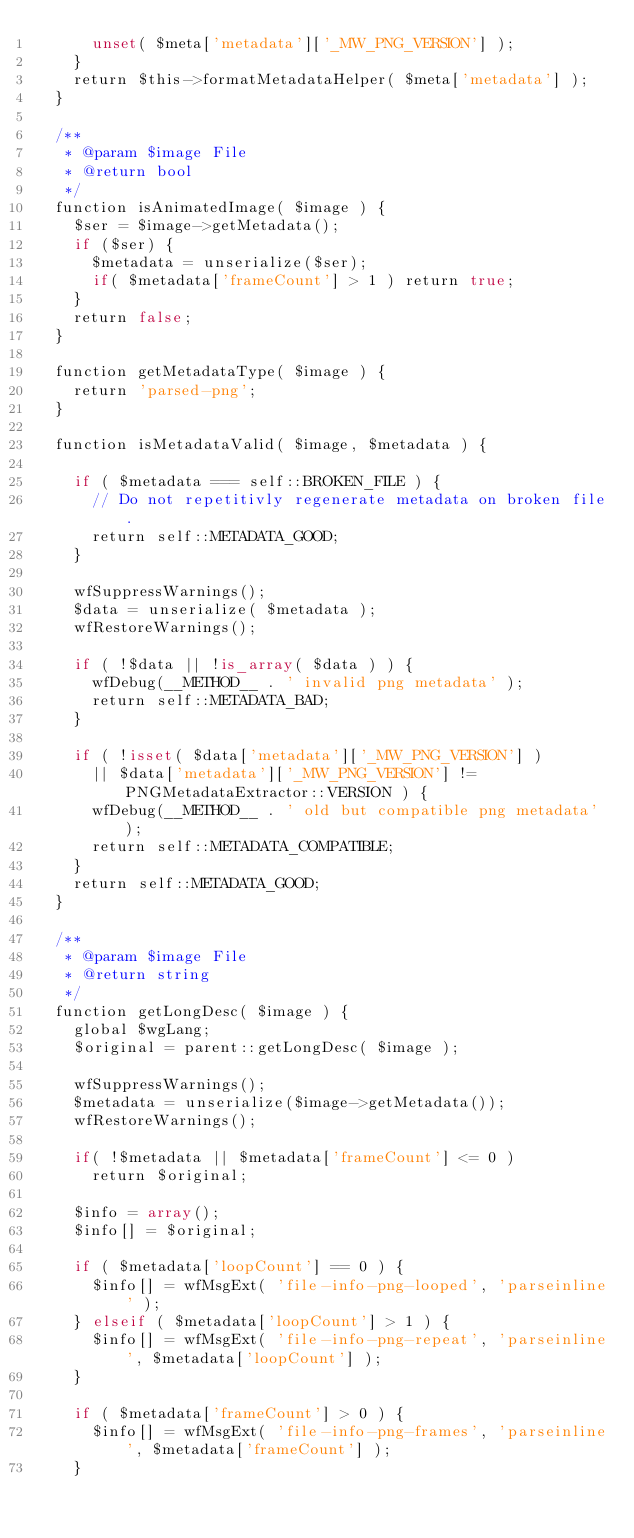<code> <loc_0><loc_0><loc_500><loc_500><_PHP_>			unset( $meta['metadata']['_MW_PNG_VERSION'] );
		}
		return $this->formatMetadataHelper( $meta['metadata'] );
	}

	/**
	 * @param $image File
	 * @return bool
	 */
	function isAnimatedImage( $image ) {
		$ser = $image->getMetadata();
		if ($ser) {
			$metadata = unserialize($ser);
			if( $metadata['frameCount'] > 1 ) return true;
		}
		return false;
	}
	
	function getMetadataType( $image ) {
		return 'parsed-png';
	}
	
	function isMetadataValid( $image, $metadata ) {

		if ( $metadata === self::BROKEN_FILE ) {
			// Do not repetitivly regenerate metadata on broken file.
			return self::METADATA_GOOD;
		}

		wfSuppressWarnings();
		$data = unserialize( $metadata );
		wfRestoreWarnings();

		if ( !$data || !is_array( $data ) ) {
			wfDebug(__METHOD__ . ' invalid png metadata' );
			return self::METADATA_BAD;
		}

		if ( !isset( $data['metadata']['_MW_PNG_VERSION'] )
			|| $data['metadata']['_MW_PNG_VERSION'] != PNGMetadataExtractor::VERSION ) {
			wfDebug(__METHOD__ . ' old but compatible png metadata' );
			return self::METADATA_COMPATIBLE;
		}
		return self::METADATA_GOOD;
	}

	/**
	 * @param $image File
	 * @return string
	 */
	function getLongDesc( $image ) {
		global $wgLang;
		$original = parent::getLongDesc( $image );

		wfSuppressWarnings();
		$metadata = unserialize($image->getMetadata());
		wfRestoreWarnings();

		if( !$metadata || $metadata['frameCount'] <= 0 )
			return $original;

		$info = array();
		$info[] = $original;
		
		if ( $metadata['loopCount'] == 0 ) {
			$info[] = wfMsgExt( 'file-info-png-looped', 'parseinline' );
		} elseif ( $metadata['loopCount'] > 1 ) {
			$info[] = wfMsgExt( 'file-info-png-repeat', 'parseinline', $metadata['loopCount'] );
		}
		
		if ( $metadata['frameCount'] > 0 ) {
			$info[] = wfMsgExt( 'file-info-png-frames', 'parseinline', $metadata['frameCount'] );
		}
		</code> 